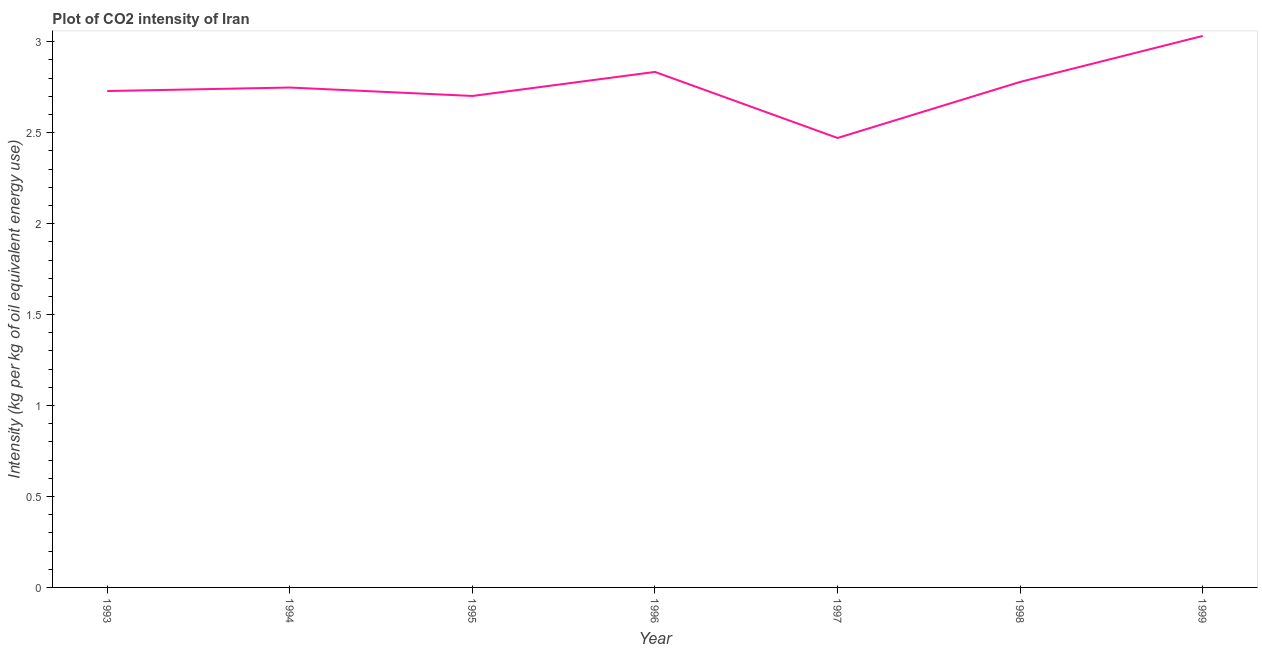What is the co2 intensity in 1993?
Provide a short and direct response. 2.73. Across all years, what is the maximum co2 intensity?
Make the answer very short. 3.03. Across all years, what is the minimum co2 intensity?
Provide a short and direct response. 2.47. In which year was the co2 intensity maximum?
Ensure brevity in your answer.  1999. What is the sum of the co2 intensity?
Ensure brevity in your answer.  19.3. What is the difference between the co2 intensity in 1998 and 1999?
Ensure brevity in your answer.  -0.25. What is the average co2 intensity per year?
Your answer should be very brief. 2.76. What is the median co2 intensity?
Offer a terse response. 2.75. Do a majority of the years between 1998 and 1996 (inclusive) have co2 intensity greater than 1.3 kg?
Provide a succinct answer. No. What is the ratio of the co2 intensity in 1995 to that in 1997?
Your answer should be very brief. 1.09. Is the co2 intensity in 1994 less than that in 1998?
Your response must be concise. Yes. What is the difference between the highest and the second highest co2 intensity?
Your answer should be compact. 0.2. What is the difference between the highest and the lowest co2 intensity?
Ensure brevity in your answer.  0.56. Does the co2 intensity monotonically increase over the years?
Offer a very short reply. No. How many lines are there?
Keep it short and to the point. 1. How many years are there in the graph?
Ensure brevity in your answer.  7. What is the title of the graph?
Make the answer very short. Plot of CO2 intensity of Iran. What is the label or title of the Y-axis?
Offer a terse response. Intensity (kg per kg of oil equivalent energy use). What is the Intensity (kg per kg of oil equivalent energy use) in 1993?
Your response must be concise. 2.73. What is the Intensity (kg per kg of oil equivalent energy use) in 1994?
Your answer should be very brief. 2.75. What is the Intensity (kg per kg of oil equivalent energy use) of 1995?
Your answer should be very brief. 2.7. What is the Intensity (kg per kg of oil equivalent energy use) in 1996?
Provide a succinct answer. 2.83. What is the Intensity (kg per kg of oil equivalent energy use) in 1997?
Provide a short and direct response. 2.47. What is the Intensity (kg per kg of oil equivalent energy use) in 1998?
Provide a short and direct response. 2.78. What is the Intensity (kg per kg of oil equivalent energy use) of 1999?
Your answer should be very brief. 3.03. What is the difference between the Intensity (kg per kg of oil equivalent energy use) in 1993 and 1994?
Your response must be concise. -0.02. What is the difference between the Intensity (kg per kg of oil equivalent energy use) in 1993 and 1995?
Make the answer very short. 0.03. What is the difference between the Intensity (kg per kg of oil equivalent energy use) in 1993 and 1996?
Make the answer very short. -0.1. What is the difference between the Intensity (kg per kg of oil equivalent energy use) in 1993 and 1997?
Provide a succinct answer. 0.26. What is the difference between the Intensity (kg per kg of oil equivalent energy use) in 1993 and 1998?
Ensure brevity in your answer.  -0.05. What is the difference between the Intensity (kg per kg of oil equivalent energy use) in 1993 and 1999?
Your answer should be compact. -0.3. What is the difference between the Intensity (kg per kg of oil equivalent energy use) in 1994 and 1995?
Keep it short and to the point. 0.05. What is the difference between the Intensity (kg per kg of oil equivalent energy use) in 1994 and 1996?
Ensure brevity in your answer.  -0.09. What is the difference between the Intensity (kg per kg of oil equivalent energy use) in 1994 and 1997?
Offer a very short reply. 0.28. What is the difference between the Intensity (kg per kg of oil equivalent energy use) in 1994 and 1998?
Provide a succinct answer. -0.03. What is the difference between the Intensity (kg per kg of oil equivalent energy use) in 1994 and 1999?
Ensure brevity in your answer.  -0.28. What is the difference between the Intensity (kg per kg of oil equivalent energy use) in 1995 and 1996?
Make the answer very short. -0.13. What is the difference between the Intensity (kg per kg of oil equivalent energy use) in 1995 and 1997?
Your response must be concise. 0.23. What is the difference between the Intensity (kg per kg of oil equivalent energy use) in 1995 and 1998?
Keep it short and to the point. -0.08. What is the difference between the Intensity (kg per kg of oil equivalent energy use) in 1995 and 1999?
Your answer should be very brief. -0.33. What is the difference between the Intensity (kg per kg of oil equivalent energy use) in 1996 and 1997?
Your answer should be compact. 0.36. What is the difference between the Intensity (kg per kg of oil equivalent energy use) in 1996 and 1998?
Provide a succinct answer. 0.05. What is the difference between the Intensity (kg per kg of oil equivalent energy use) in 1996 and 1999?
Your answer should be compact. -0.2. What is the difference between the Intensity (kg per kg of oil equivalent energy use) in 1997 and 1998?
Your response must be concise. -0.31. What is the difference between the Intensity (kg per kg of oil equivalent energy use) in 1997 and 1999?
Ensure brevity in your answer.  -0.56. What is the difference between the Intensity (kg per kg of oil equivalent energy use) in 1998 and 1999?
Your answer should be very brief. -0.25. What is the ratio of the Intensity (kg per kg of oil equivalent energy use) in 1993 to that in 1994?
Offer a terse response. 0.99. What is the ratio of the Intensity (kg per kg of oil equivalent energy use) in 1993 to that in 1996?
Ensure brevity in your answer.  0.96. What is the ratio of the Intensity (kg per kg of oil equivalent energy use) in 1993 to that in 1997?
Your answer should be compact. 1.1. What is the ratio of the Intensity (kg per kg of oil equivalent energy use) in 1993 to that in 1998?
Offer a very short reply. 0.98. What is the ratio of the Intensity (kg per kg of oil equivalent energy use) in 1993 to that in 1999?
Ensure brevity in your answer.  0.9. What is the ratio of the Intensity (kg per kg of oil equivalent energy use) in 1994 to that in 1995?
Ensure brevity in your answer.  1.02. What is the ratio of the Intensity (kg per kg of oil equivalent energy use) in 1994 to that in 1997?
Your answer should be compact. 1.11. What is the ratio of the Intensity (kg per kg of oil equivalent energy use) in 1994 to that in 1998?
Give a very brief answer. 0.99. What is the ratio of the Intensity (kg per kg of oil equivalent energy use) in 1994 to that in 1999?
Make the answer very short. 0.91. What is the ratio of the Intensity (kg per kg of oil equivalent energy use) in 1995 to that in 1996?
Make the answer very short. 0.95. What is the ratio of the Intensity (kg per kg of oil equivalent energy use) in 1995 to that in 1997?
Your response must be concise. 1.09. What is the ratio of the Intensity (kg per kg of oil equivalent energy use) in 1995 to that in 1999?
Offer a very short reply. 0.89. What is the ratio of the Intensity (kg per kg of oil equivalent energy use) in 1996 to that in 1997?
Offer a terse response. 1.15. What is the ratio of the Intensity (kg per kg of oil equivalent energy use) in 1996 to that in 1999?
Give a very brief answer. 0.94. What is the ratio of the Intensity (kg per kg of oil equivalent energy use) in 1997 to that in 1998?
Your response must be concise. 0.89. What is the ratio of the Intensity (kg per kg of oil equivalent energy use) in 1997 to that in 1999?
Your answer should be compact. 0.81. What is the ratio of the Intensity (kg per kg of oil equivalent energy use) in 1998 to that in 1999?
Your response must be concise. 0.92. 